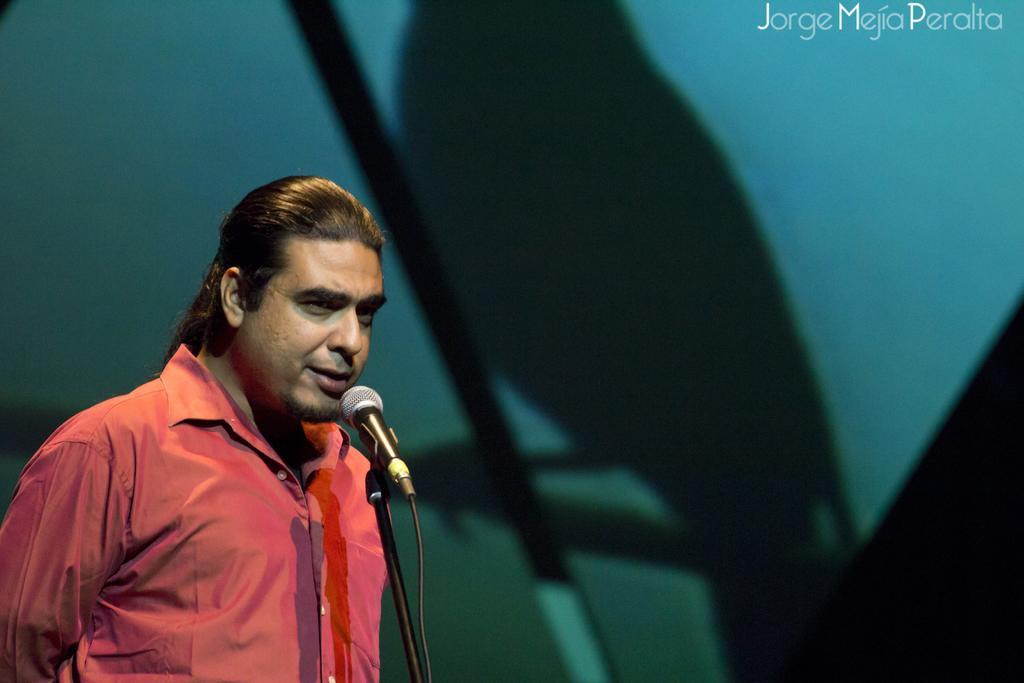How would you summarize this image in a sentence or two? In this image in the front there is a man standing and speaking in front of the mic which is in the center. In the background there is a shadow of a bird. 